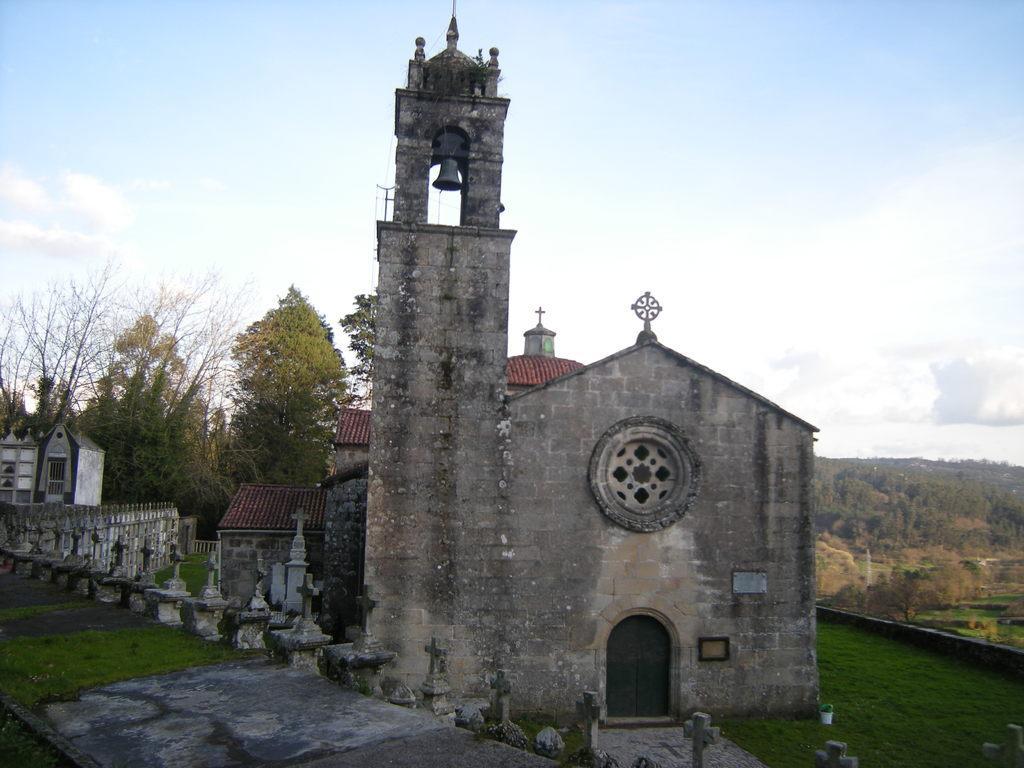Can you describe this image briefly? This image consists of a building along with a door. At the bottom, there is green grass on the ground. At the top, we can see a bell. In the middle, there are trees. On the right, there are trees and mountains. At the top, there are clouds in the sky. 